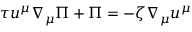Convert formula to latex. <formula><loc_0><loc_0><loc_500><loc_500>\tau u ^ { \mu } \nabla _ { \mu } \Pi + \Pi = - \zeta \nabla _ { \mu } u ^ { \mu }</formula> 